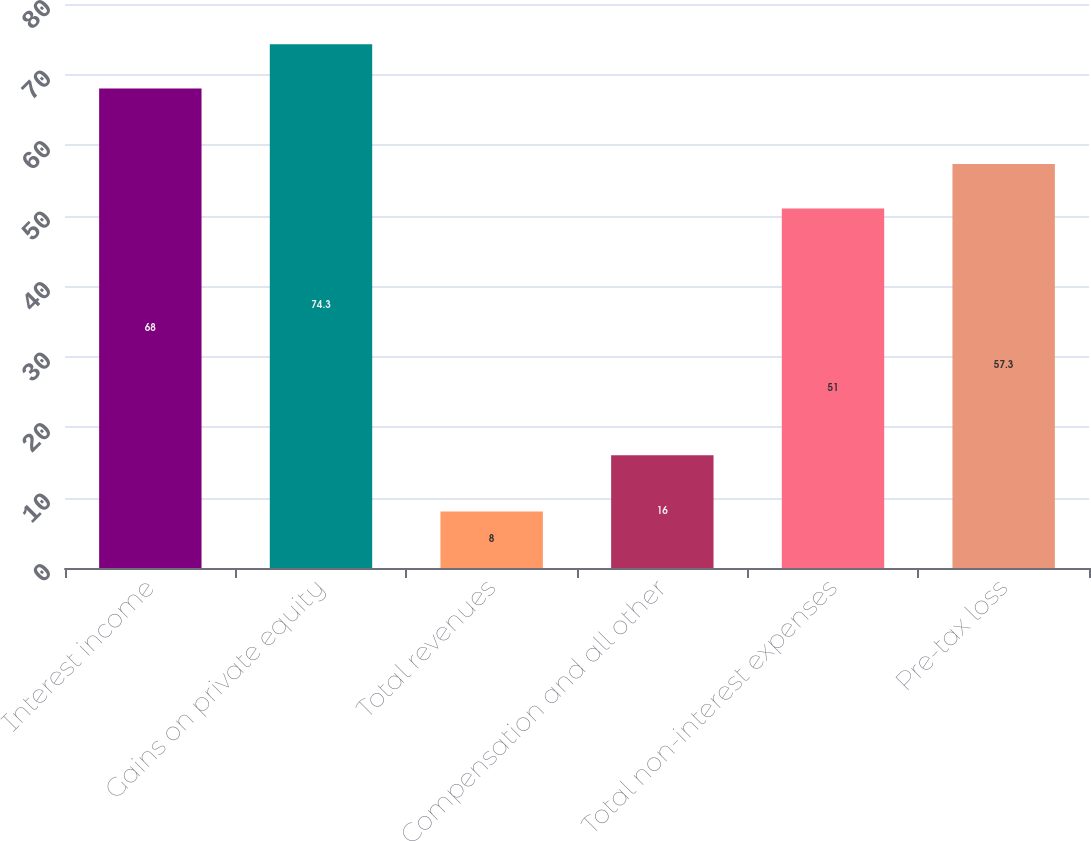Convert chart. <chart><loc_0><loc_0><loc_500><loc_500><bar_chart><fcel>Interest income<fcel>Gains on private equity<fcel>Total revenues<fcel>Compensation and all other<fcel>Total non-interest expenses<fcel>Pre-tax loss<nl><fcel>68<fcel>74.3<fcel>8<fcel>16<fcel>51<fcel>57.3<nl></chart> 